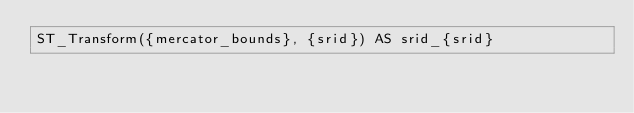Convert code to text. <code><loc_0><loc_0><loc_500><loc_500><_SQL_>ST_Transform({mercator_bounds}, {srid}) AS srid_{srid}</code> 